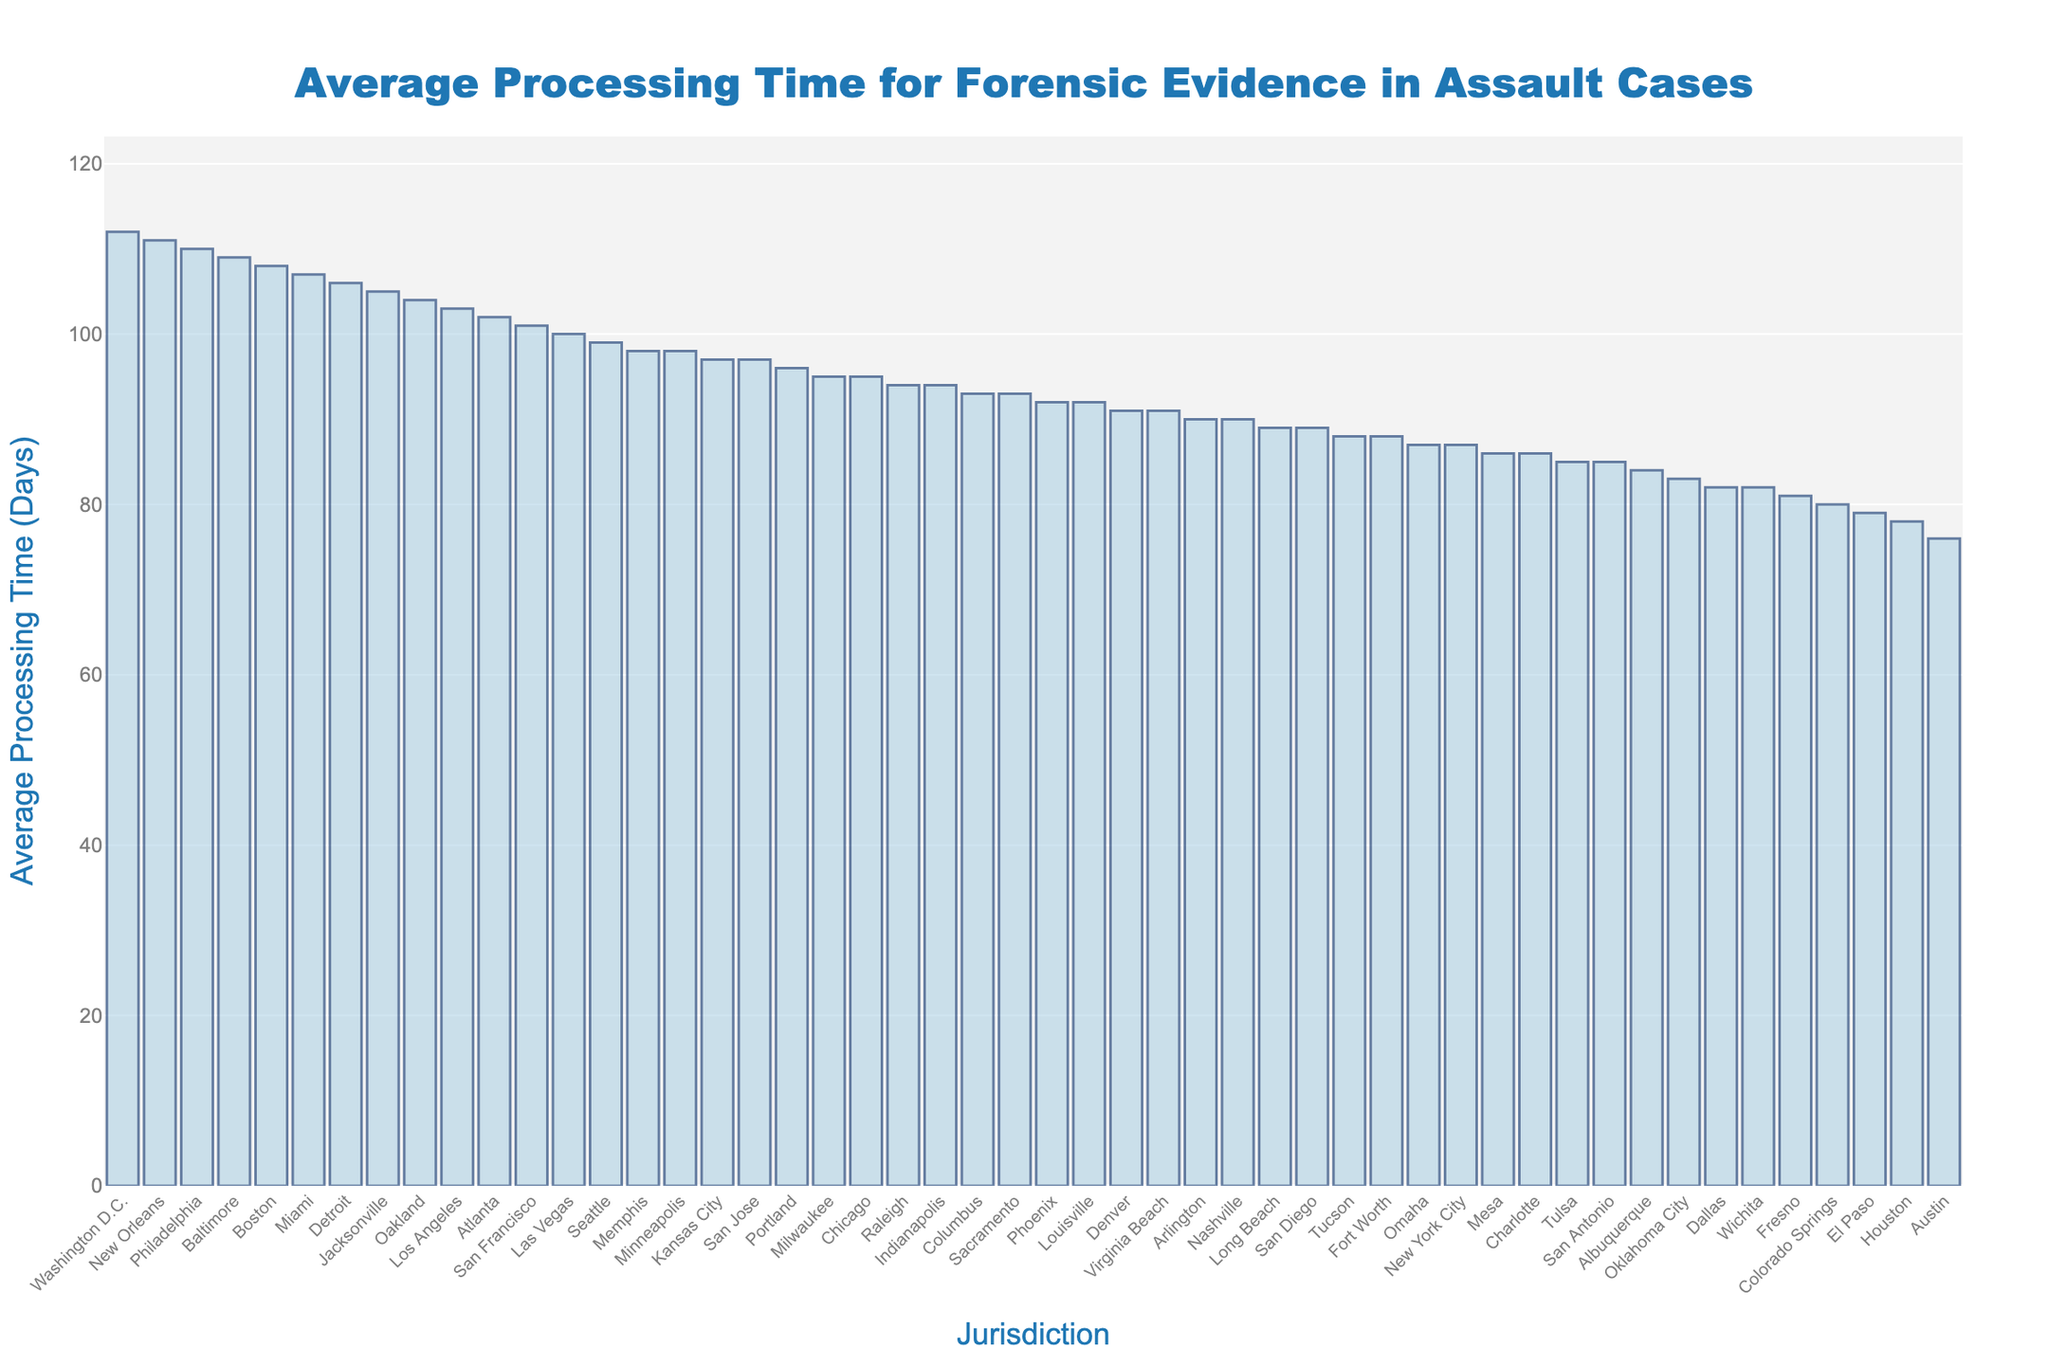Which jurisdiction has the longest average processing time for forensic evidence? By looking at the bar heights, the longest average processing time is for Washington D.C.
Answer: Washington D.C Which jurisdictions have an average processing time greater than 100 days? The jurisdictions with a processing time greater than 100 days can be identified by finding the bars that exceed the 100-day mark: Washington D.C., Los Angeles, Philadelphia, Jacksonville, Oakland, Boston, Detroit, New Orleans, Miami.
Answer: Washington D.C., Los Angeles, Philadelphia, Jacksonville, Oakland, Boston, Detroit, New Orleans, Miami What is the difference in average processing time between New York City and Los Angeles? Find the average processing time for New York City (87 days) and Los Angeles (103 days), then calculate the difference: 103 - 87 = 16 days.
Answer: 16 days Which jurisdictions have a processing time less than 80 days? By observing the bar heights, Austin, Houston, El Paso, and Colorado Springs are below the 80-day mark.
Answer: Austin, Houston, El Paso, Colorado Springs What is the average processing time for forensic evidence across all jurisdictions? First, add up all the average processing times: 87 + 103 + 95 + ... + 82 = 4390 days. There are 50 jurisdictions, so the average is 4390 / 50 = 87.8 days.
Answer: 87.8 days Which has a higher average processing time: Boston or Chicago? By observing the bar heights, Boston's average processing time (108 days) is higher than Chicago's (95 days).
Answer: Boston What’s the median processing time for forensic evidence across all jurisdictions? Sort the processing times and find the middle value(s). With 50 values, the median is the average of the 25th and 26th values in the sorted list. These values are 94 (Raleigh) and 94 (Indianapolis), so the median is (94 + 94) / 2 = 94 days.
Answer: 94 days Which jurisdictions have an average processing time exactly equal to 90 days? Checking the bars, Nashville and Arlington have an average processing time of 90 days.
Answer: Nashville, Arlington By how many days does Washington D.C. exceed the jurisdiction with the second-highest average processing time? Washington D.C. has 112 days and Philadelphia has 110 days. The difference is 112 - 110 = 2 days.
Answer: 2 days What is the combined average processing time for Phoenix, Seattle, and Portland? Add the processing times for these jurisdictions: Phoenix (92 days), Seattle (99 days), and Portland (96 days). The combined time is 92 + 99 + 96 = 287 days.
Answer: 287 days 